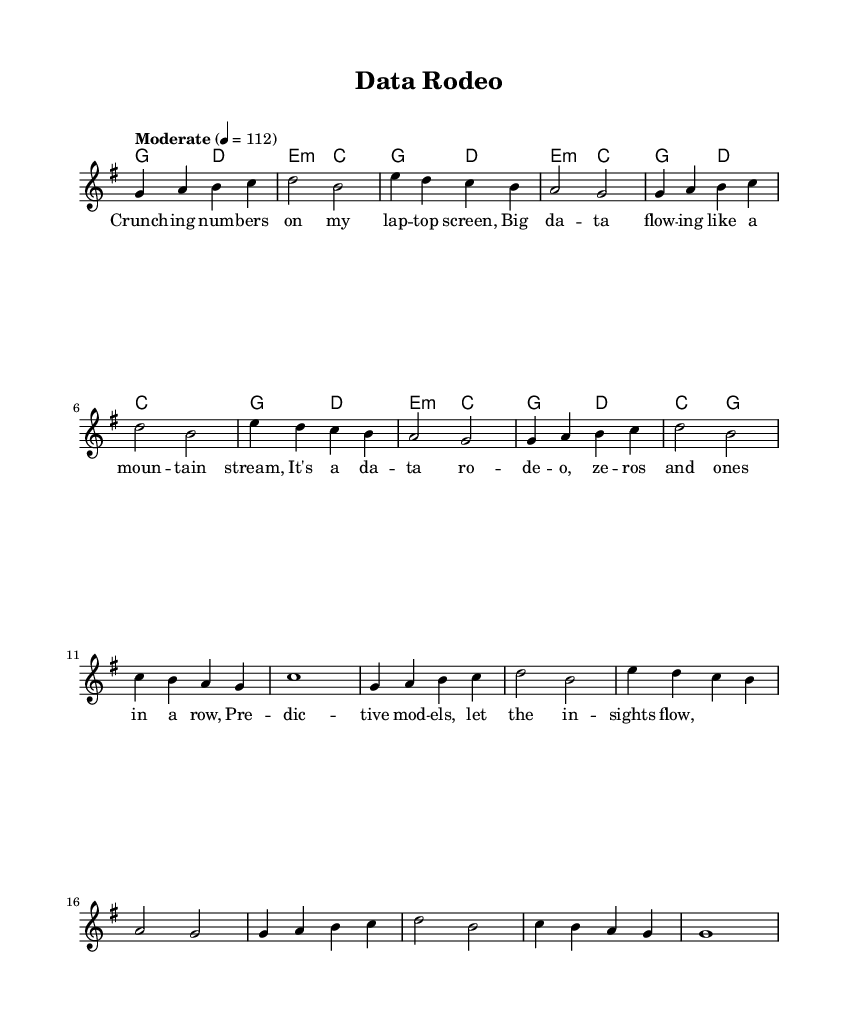What is the key signature of this music? The key signature is G major, which has one sharp (F#). This can be identified in the key signature section found at the beginning of the staff.
Answer: G major What is the time signature of this music? The time signature is 4/4, indicated at the beginning of the score. This means there are four beats in a measure, and the quarter note receives one beat.
Answer: 4/4 What is the tempo marking for this piece? The tempo is marked as "Moderate" with a tempo of 112 beats per minute. This provides a speed description that can be found near the beginning of the score.
Answer: Moderate 4 = 112 How many measures are in the chorus section? The chorus consists of four measures, as counted from the notation specifically grouped under the chorus lyrics section.
Answer: 4 Which chord appears most frequently in the harmony line throughout the piece? The G major chord appears consistently in both the verses and chorus sections, signifying a harmony center throughout the song's structure.
Answer: G major What is the rhythmic value of the first note in the intro? The first note in the intro is a quarter note, as indicated by the notation on the score where it is displayed in a single quarter note duration.
Answer: Quarter note 